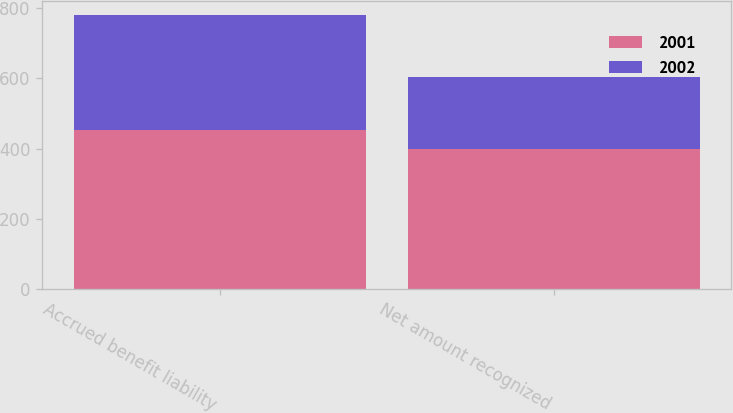Convert chart. <chart><loc_0><loc_0><loc_500><loc_500><stacked_bar_chart><ecel><fcel>Accrued benefit liability<fcel>Net amount recognized<nl><fcel>2001<fcel>453<fcel>399<nl><fcel>2002<fcel>328<fcel>205<nl></chart> 